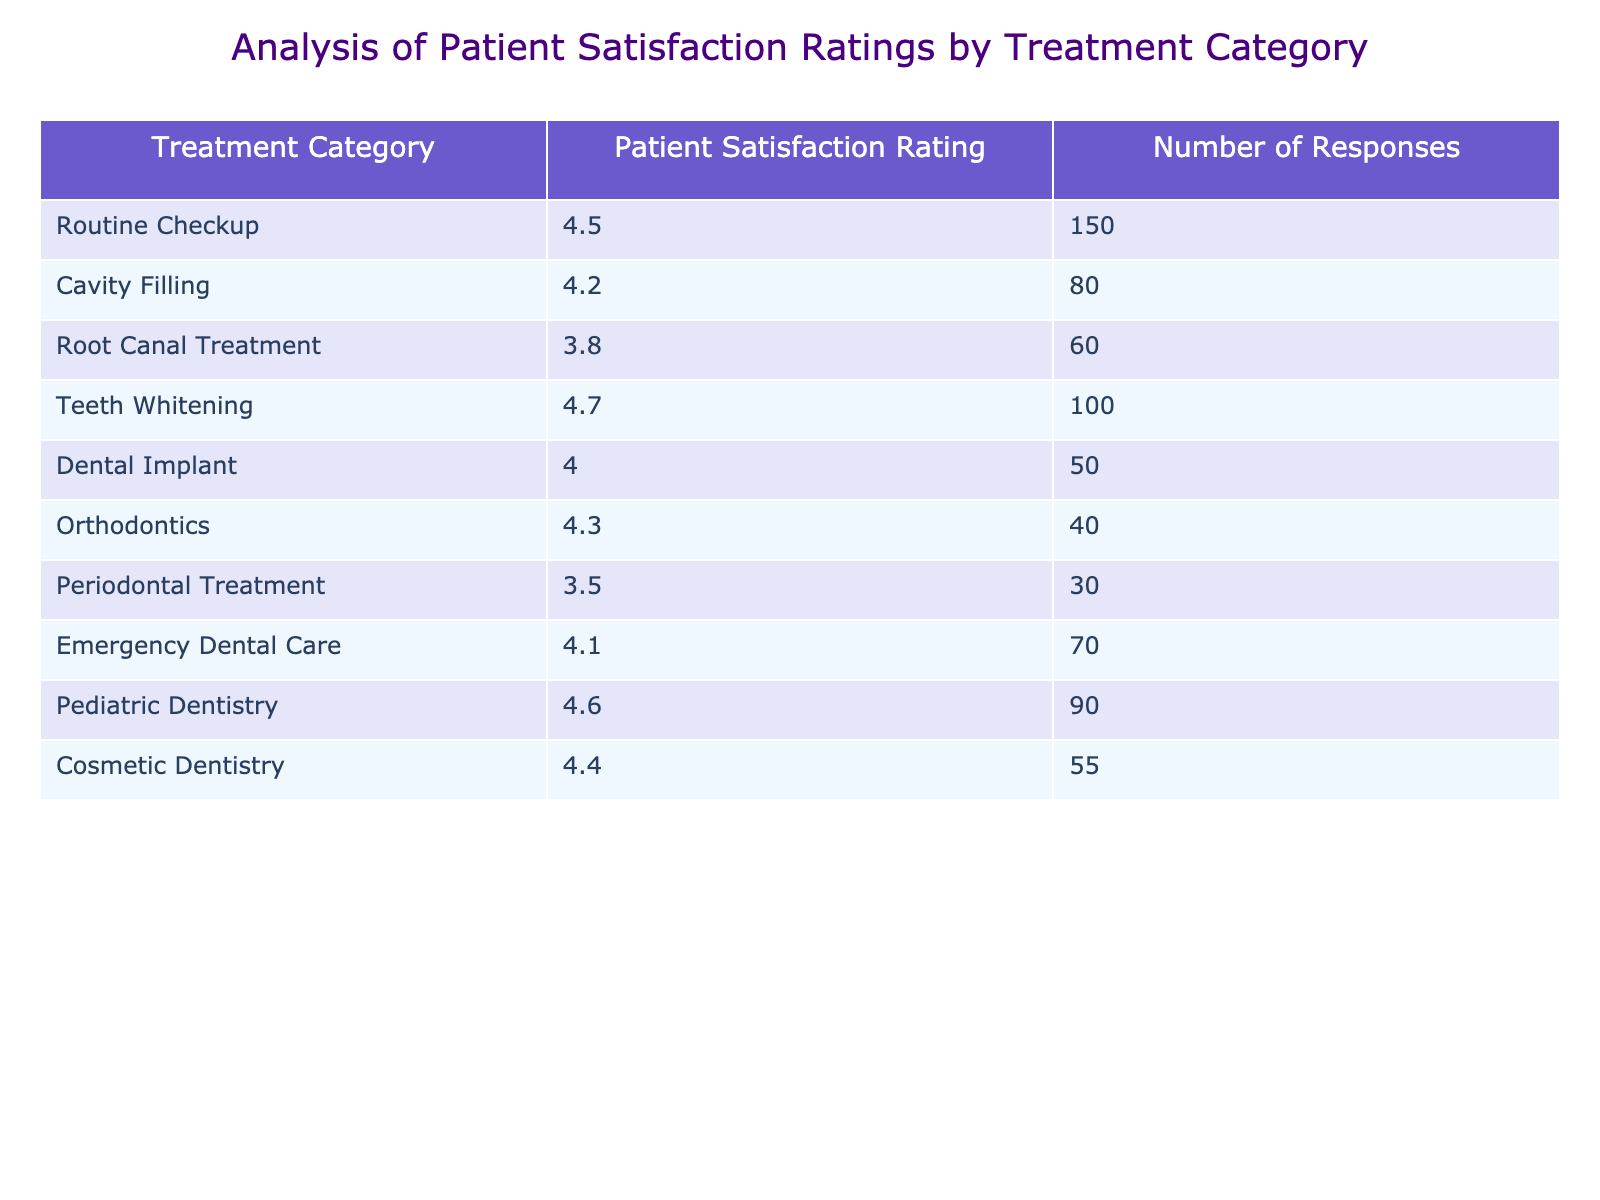What is the Patient Satisfaction Rating for Teeth Whitening? The table indicates that the Patient Satisfaction Rating for Teeth Whitening is 4.7.
Answer: 4.7 Which treatment category has the lowest Patient Satisfaction Rating? The lowest Patient Satisfaction Rating in the table is for Periodontal Treatment, which has a rating of 3.5.
Answer: Periodontal Treatment How many responses were collected for Cavity Filling? According to the table, there were 80 responses collected for Cavity Filling.
Answer: 80 What is the average Patient Satisfaction Rating for treatments with more than 70 responses? The treatments with more than 70 responses are Routine Checkup (4.5), Cavity Filling (4.2), Teeth Whitening (4.7), Emergency Dental Care (4.1), and Pediatric Dentistry (4.6). Summing those ratings gives 4.5 + 4.2 + 4.7 + 4.1 + 4.6 = 22.1. There are 5 treatments, so the average rating is 22.1 / 5 = 4.42.
Answer: 4.42 Is the Patient Satisfaction Rating for Dental Implants higher than that for Root Canal Treatment? The Patient Satisfaction Rating for Dental Implants is 4.0 and for Root Canal Treatment, it is 3.8. Since 4.0 is greater than 3.8, the statement is true.
Answer: Yes How many more responses did Routine Checkup receive compared to Orthodontics? Routine Checkup received 150 responses while Orthodontics received 40 responses. The difference is 150 - 40 = 110.
Answer: 110 Which treatment category has more responses, Pediatric Dentistry or Teeth Whitening? Pediatric Dentistry has 90 responses, while Teeth Whitening has 100 responses. Since 100 > 90, Teeth Whitening has more responses.
Answer: Teeth Whitening If we combined the Patient Satisfaction Ratings for all treatments, what is the total? By summing all the Patient Satisfaction Ratings: 4.5 + 4.2 + 3.8 + 4.7 + 4.0 + 4.3 + 3.5 + 4.1 + 4.6 + 4.4 = 46.1.
Answer: 46.1 Are there more treatments with a Patient Satisfaction Rating above 4.0 or below 4.0? The treatments with a Patient Satisfaction Rating above 4.0 are Routine Checkup, Teeth Whitening, Pediatric Dentistry, Cosmetic Dentistry, Orthodontics, and Emergency Dental Care for a total of 6 treatments. Those below 4.0 include Cavity Filling, Root Canal Treatment, Dental Implant, and Periodontal Treatment totaling 4 treatments. So, there are more above 4.0.
Answer: Yes 